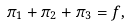<formula> <loc_0><loc_0><loc_500><loc_500>\pi _ { 1 } + \pi _ { 2 } + \pi _ { 3 } = f ,</formula> 